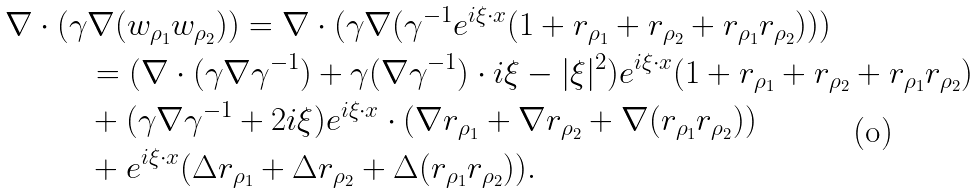<formula> <loc_0><loc_0><loc_500><loc_500>\nabla \cdot ( \gamma & \nabla ( w _ { \rho _ { 1 } } w _ { \rho _ { 2 } } ) ) = \nabla \cdot ( \gamma \nabla ( \gamma ^ { - 1 } e ^ { i \xi \cdot x } ( 1 + r _ { \rho _ { 1 } } + r _ { \rho _ { 2 } } + r _ { \rho _ { 1 } } r _ { \rho _ { 2 } } ) ) ) \\ & = ( \nabla \cdot ( \gamma \nabla \gamma ^ { - 1 } ) + \gamma ( \nabla \gamma ^ { - 1 } ) \cdot i \xi - | \xi | ^ { 2 } ) e ^ { i \xi \cdot x } ( 1 + r _ { \rho _ { 1 } } + r _ { \rho _ { 2 } } + r _ { \rho _ { 1 } } r _ { \rho _ { 2 } } ) \\ & + ( \gamma \nabla \gamma ^ { - 1 } + 2 i \xi ) e ^ { i \xi \cdot x } \cdot ( \nabla r _ { \rho _ { 1 } } + \nabla r _ { \rho _ { 2 } } + \nabla ( r _ { \rho _ { 1 } } r _ { \rho _ { 2 } } ) ) \\ & + e ^ { i \xi \cdot x } ( \Delta r _ { \rho _ { 1 } } + \Delta r _ { \rho _ { 2 } } + \Delta ( r _ { \rho _ { 1 } } r _ { \rho _ { 2 } } ) ) .</formula> 